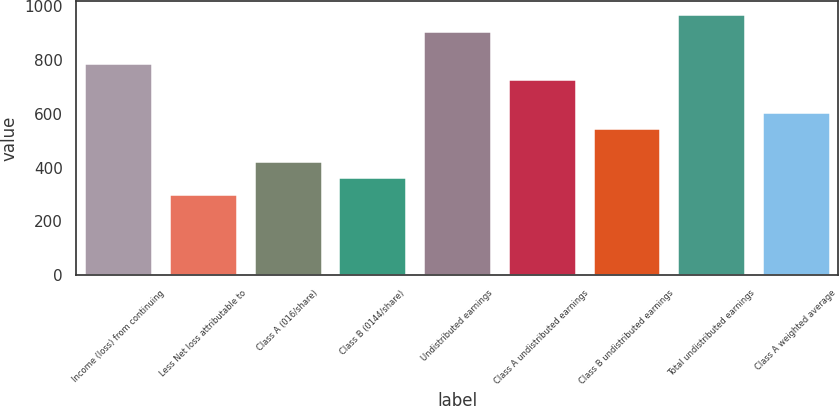Convert chart to OTSL. <chart><loc_0><loc_0><loc_500><loc_500><bar_chart><fcel>Income (loss) from continuing<fcel>Less Net loss attributable to<fcel>Class A (016/share)<fcel>Class B (0144/share)<fcel>Undistributed earnings<fcel>Class A undistributed earnings<fcel>Class B undistributed earnings<fcel>Total undistributed earnings<fcel>Class A weighted average<nl><fcel>787.67<fcel>303.11<fcel>424.25<fcel>363.68<fcel>908.81<fcel>727.1<fcel>545.39<fcel>969.38<fcel>605.96<nl></chart> 